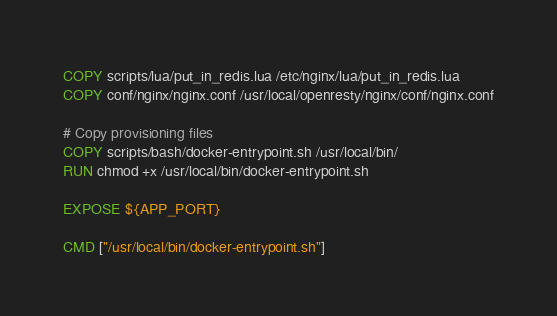<code> <loc_0><loc_0><loc_500><loc_500><_Dockerfile_>COPY scripts/lua/put_in_redis.lua /etc/nginx/lua/put_in_redis.lua
COPY conf/nginx/nginx.conf /usr/local/openresty/nginx/conf/nginx.conf

# Copy provisioning files
COPY scripts/bash/docker-entrypoint.sh /usr/local/bin/
RUN chmod +x /usr/local/bin/docker-entrypoint.sh

EXPOSE ${APP_PORT}

CMD ["/usr/local/bin/docker-entrypoint.sh"]</code> 